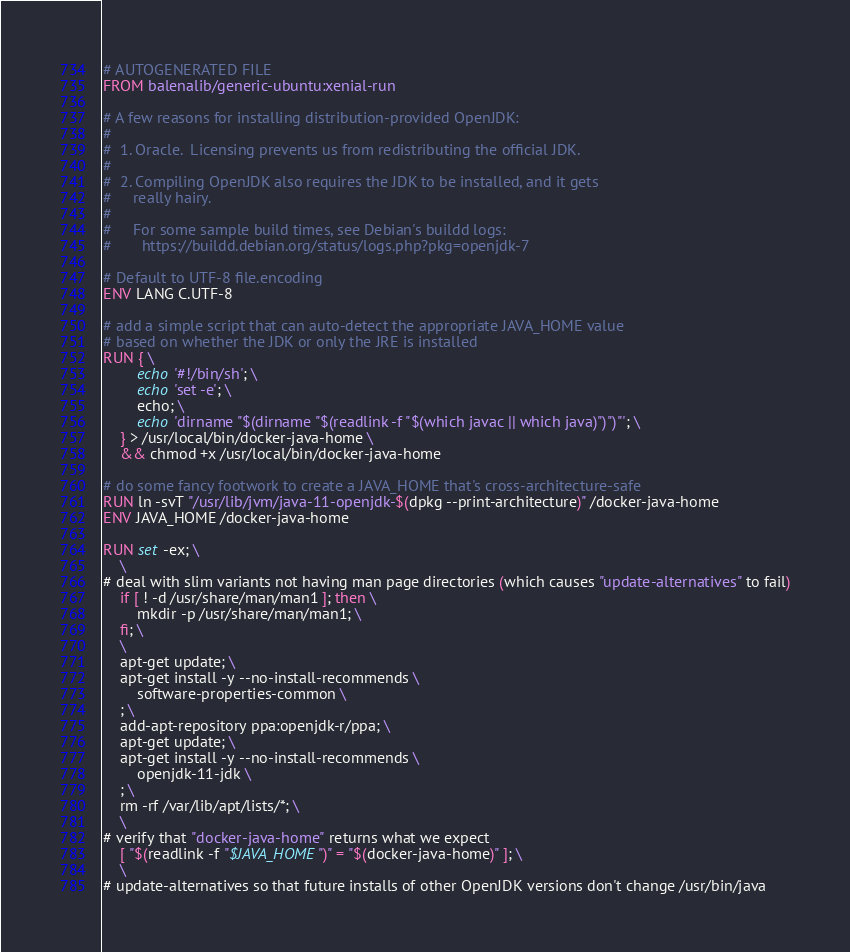<code> <loc_0><loc_0><loc_500><loc_500><_Dockerfile_># AUTOGENERATED FILE
FROM balenalib/generic-ubuntu:xenial-run

# A few reasons for installing distribution-provided OpenJDK:
#
#  1. Oracle.  Licensing prevents us from redistributing the official JDK.
#
#  2. Compiling OpenJDK also requires the JDK to be installed, and it gets
#     really hairy.
#
#     For some sample build times, see Debian's buildd logs:
#       https://buildd.debian.org/status/logs.php?pkg=openjdk-7

# Default to UTF-8 file.encoding
ENV LANG C.UTF-8

# add a simple script that can auto-detect the appropriate JAVA_HOME value
# based on whether the JDK or only the JRE is installed
RUN { \
		echo '#!/bin/sh'; \
		echo 'set -e'; \
		echo; \
		echo 'dirname "$(dirname "$(readlink -f "$(which javac || which java)")")"'; \
	} > /usr/local/bin/docker-java-home \
	&& chmod +x /usr/local/bin/docker-java-home

# do some fancy footwork to create a JAVA_HOME that's cross-architecture-safe
RUN ln -svT "/usr/lib/jvm/java-11-openjdk-$(dpkg --print-architecture)" /docker-java-home
ENV JAVA_HOME /docker-java-home

RUN set -ex; \
	\
# deal with slim variants not having man page directories (which causes "update-alternatives" to fail)
	if [ ! -d /usr/share/man/man1 ]; then \
		mkdir -p /usr/share/man/man1; \
	fi; \
	\
	apt-get update; \
	apt-get install -y --no-install-recommends \
		software-properties-common \
	; \
	add-apt-repository ppa:openjdk-r/ppa; \
	apt-get update; \
	apt-get install -y --no-install-recommends \
		openjdk-11-jdk \
	; \
	rm -rf /var/lib/apt/lists/*; \
	\
# verify that "docker-java-home" returns what we expect
	[ "$(readlink -f "$JAVA_HOME")" = "$(docker-java-home)" ]; \
	\
# update-alternatives so that future installs of other OpenJDK versions don't change /usr/bin/java</code> 